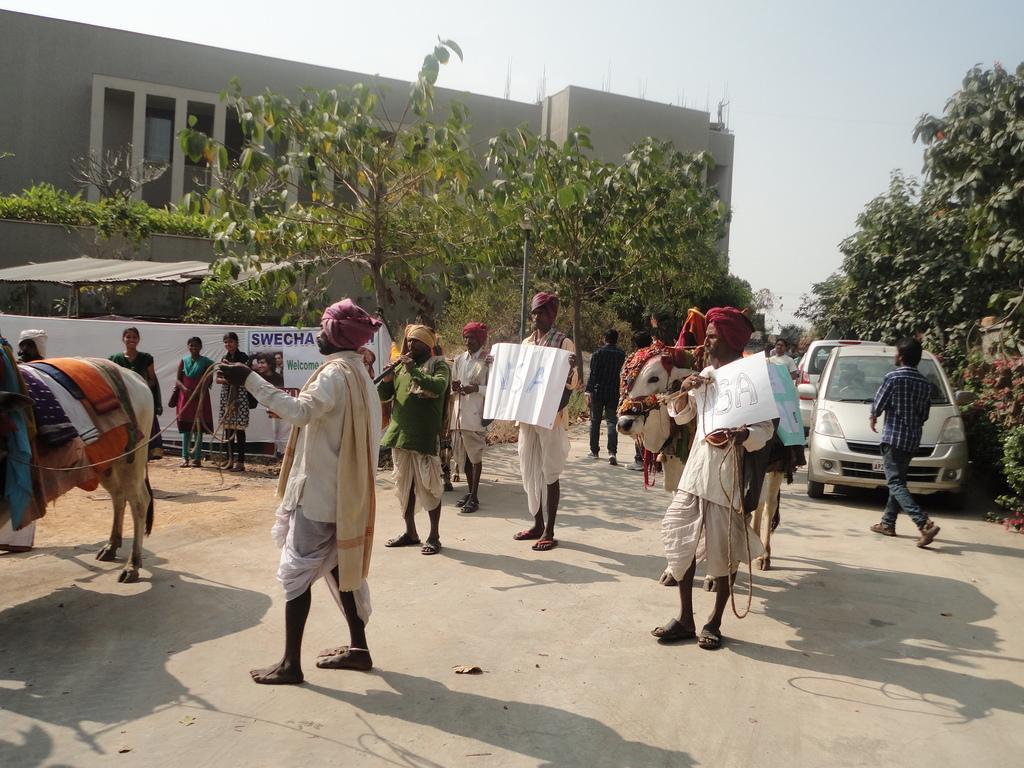How would you summarize this image in a sentence or two? In this image people are standing on the road. Few animals which are decorated with the clothes are on the road. Few people are on the road. Few people are standing on the land. Left side there is a banner. Right side there are vehicles on the road. A person is walking on the road. Background there are trees. Left side there is a building. Top of the image there is sky. Few people are holding the boards and few people are holding the musical instruments. 